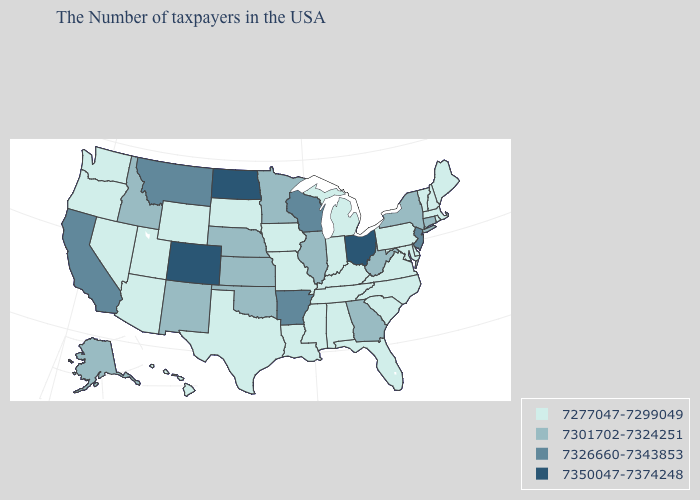Does Alabama have a lower value than Vermont?
Be succinct. No. Among the states that border Montana , does North Dakota have the highest value?
Answer briefly. Yes. What is the highest value in states that border South Dakota?
Be succinct. 7350047-7374248. Name the states that have a value in the range 7326660-7343853?
Quick response, please. New Jersey, Wisconsin, Arkansas, Montana, California. What is the highest value in states that border Wyoming?
Short answer required. 7350047-7374248. Name the states that have a value in the range 7301702-7324251?
Give a very brief answer. Connecticut, New York, West Virginia, Georgia, Illinois, Minnesota, Kansas, Nebraska, Oklahoma, New Mexico, Idaho, Alaska. Among the states that border Texas , which have the highest value?
Keep it brief. Arkansas. Does Michigan have a higher value than Ohio?
Quick response, please. No. What is the highest value in the USA?
Quick response, please. 7350047-7374248. What is the lowest value in the Northeast?
Be succinct. 7277047-7299049. Which states hav the highest value in the West?
Concise answer only. Colorado. Which states hav the highest value in the West?
Give a very brief answer. Colorado. Among the states that border Utah , which have the lowest value?
Give a very brief answer. Wyoming, Arizona, Nevada. What is the value of Alabama?
Keep it brief. 7277047-7299049. Does New York have the lowest value in the USA?
Short answer required. No. 